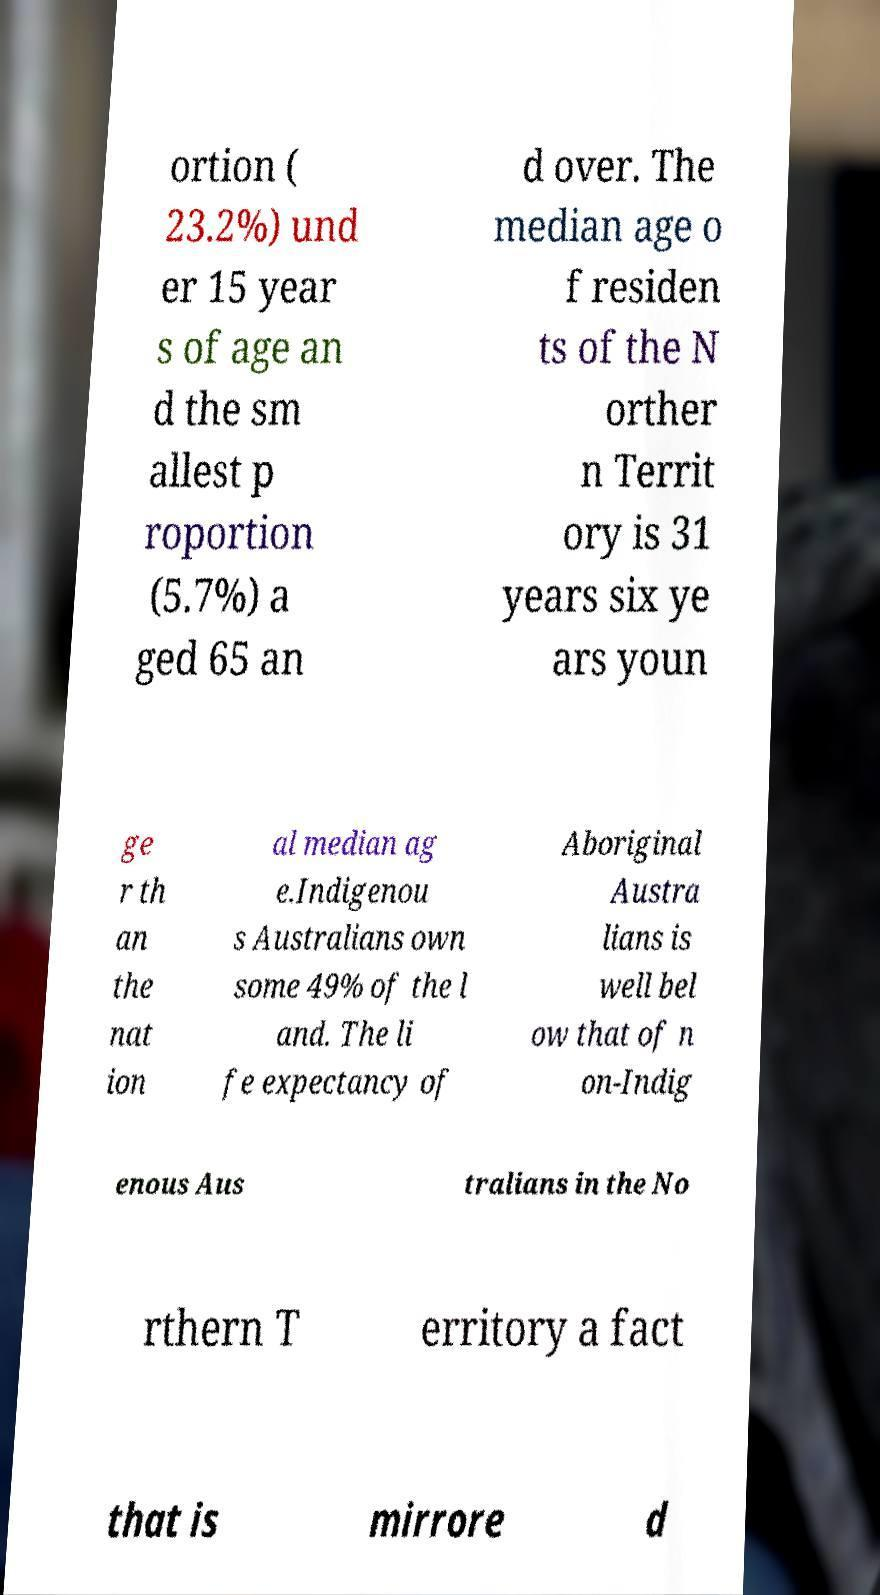For documentation purposes, I need the text within this image transcribed. Could you provide that? ortion ( 23.2%) und er 15 year s of age an d the sm allest p roportion (5.7%) a ged 65 an d over. The median age o f residen ts of the N orther n Territ ory is 31 years six ye ars youn ge r th an the nat ion al median ag e.Indigenou s Australians own some 49% of the l and. The li fe expectancy of Aboriginal Austra lians is well bel ow that of n on-Indig enous Aus tralians in the No rthern T erritory a fact that is mirrore d 